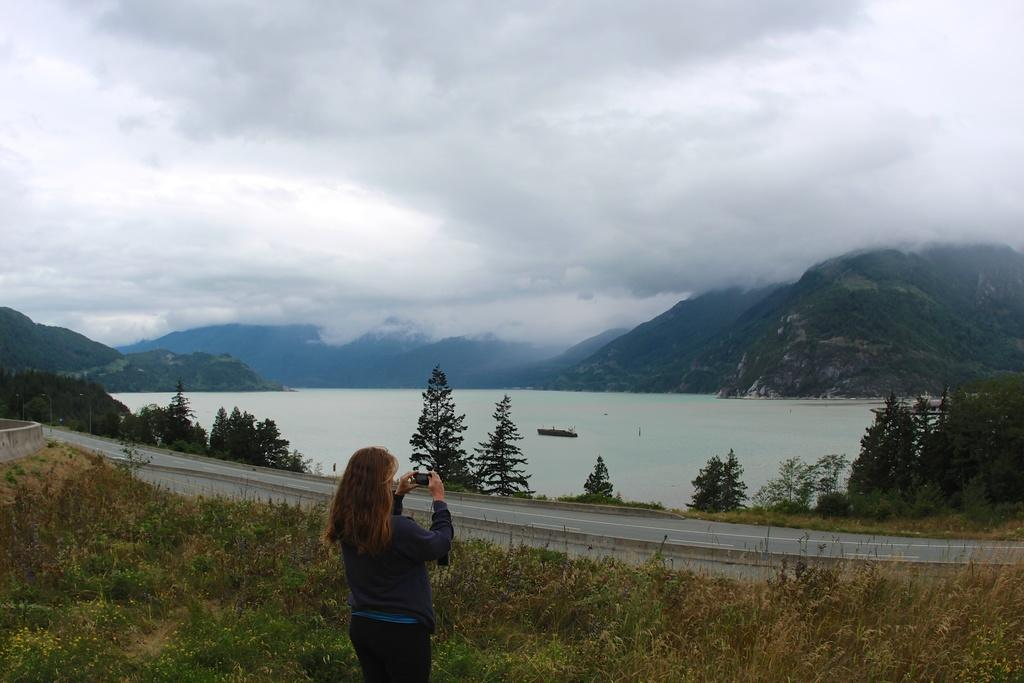Who is present in the image? There is a woman in the image. What is the woman holding? The woman is holding a mobile. What is the woman's posture in the image? The woman is standing. What type of natural environment can be seen in the image? There are trees, mountains, and a boat on water in the image. What is visible in the background of the image? The sky is visible in the background, with clouds present. What type of humor can be seen in the image? There is no humor present in the image; it is a scene featuring a woman, a mobile, and a natural environment. What type of steel is used to construct the boat in the image? There is no information about the boat's construction materials in the image. 